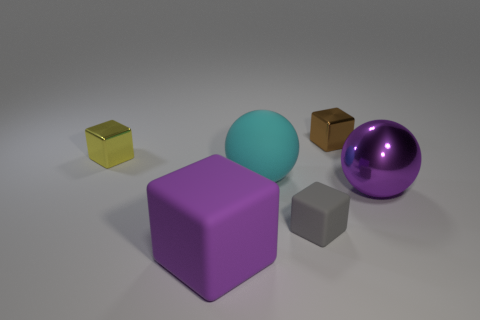There is a metallic ball; is it the same color as the rubber thing that is in front of the gray block?
Your response must be concise. Yes. There is a yellow shiny object that is the same shape as the tiny gray thing; what size is it?
Ensure brevity in your answer.  Small. Are there the same number of tiny yellow metal objects to the right of the purple cube and small red shiny blocks?
Make the answer very short. Yes. What shape is the big object that is the same color as the shiny sphere?
Your response must be concise. Cube. What number of matte blocks are the same size as the brown shiny cube?
Ensure brevity in your answer.  1. There is a large cyan ball; how many tiny gray matte blocks are on the left side of it?
Offer a very short reply. 0. What is the purple object that is right of the small block that is behind the yellow block made of?
Ensure brevity in your answer.  Metal. Are there any metal spheres of the same color as the big cube?
Ensure brevity in your answer.  Yes. What size is the purple ball that is made of the same material as the small yellow cube?
Provide a succinct answer. Large. Are there any other things of the same color as the small matte thing?
Make the answer very short. No. 